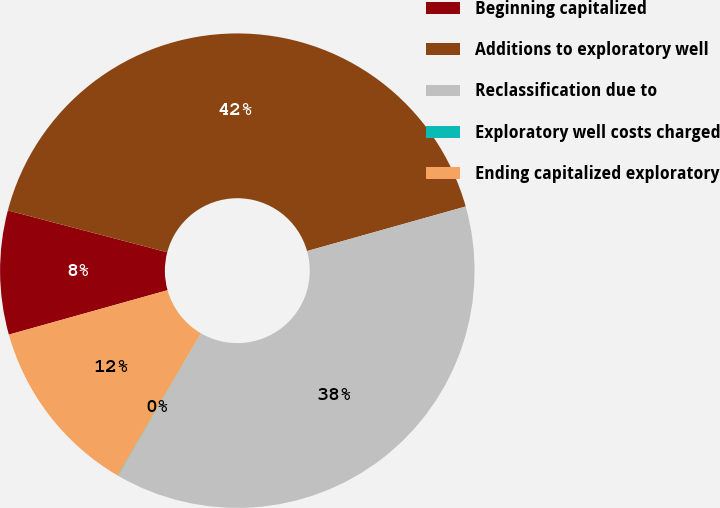<chart> <loc_0><loc_0><loc_500><loc_500><pie_chart><fcel>Beginning capitalized<fcel>Additions to exploratory well<fcel>Reclassification due to<fcel>Exploratory well costs charged<fcel>Ending capitalized exploratory<nl><fcel>8.43%<fcel>41.55%<fcel>37.73%<fcel>0.03%<fcel>12.25%<nl></chart> 